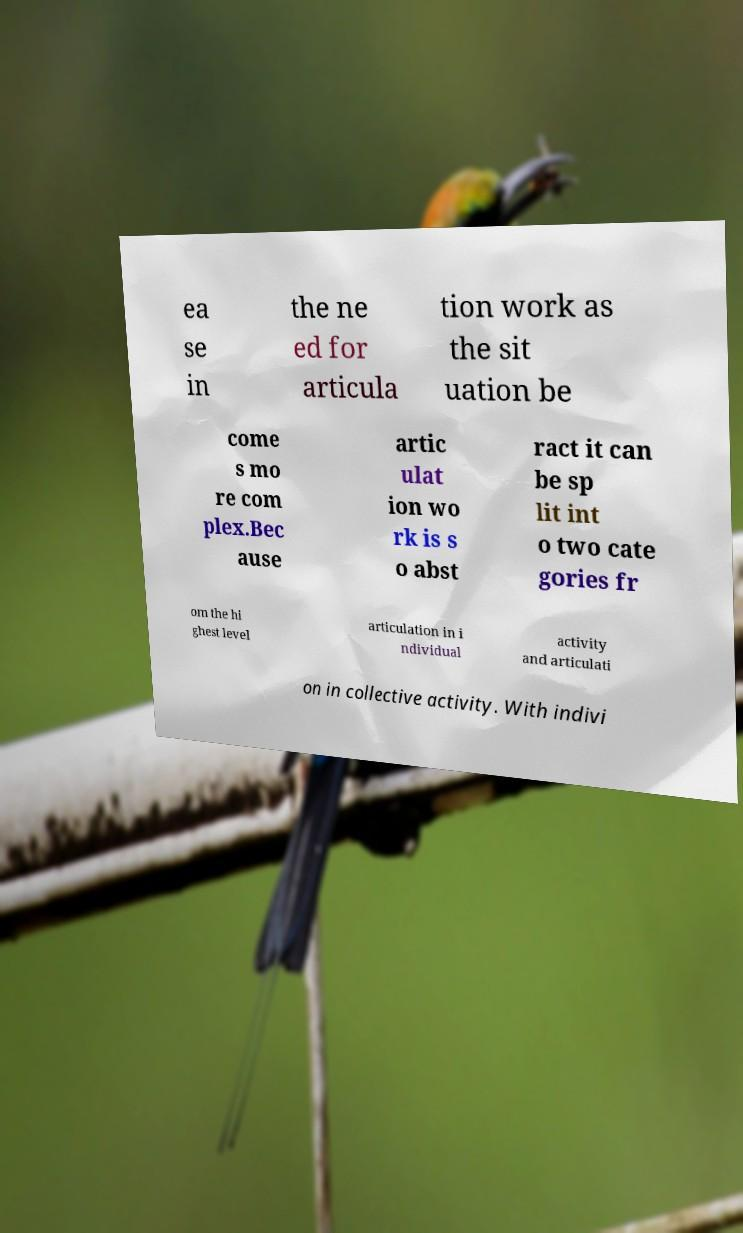What messages or text are displayed in this image? I need them in a readable, typed format. ea se in the ne ed for articula tion work as the sit uation be come s mo re com plex.Bec ause artic ulat ion wo rk is s o abst ract it can be sp lit int o two cate gories fr om the hi ghest level articulation in i ndividual activity and articulati on in collective activity. With indivi 